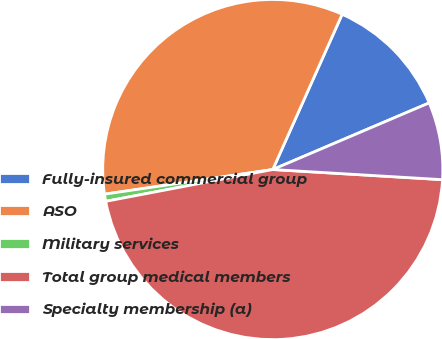Convert chart to OTSL. <chart><loc_0><loc_0><loc_500><loc_500><pie_chart><fcel>Fully-insured commercial group<fcel>ASO<fcel>Military services<fcel>Total group medical members<fcel>Specialty membership (a)<nl><fcel>11.9%<fcel>34.0%<fcel>0.68%<fcel>46.05%<fcel>7.36%<nl></chart> 